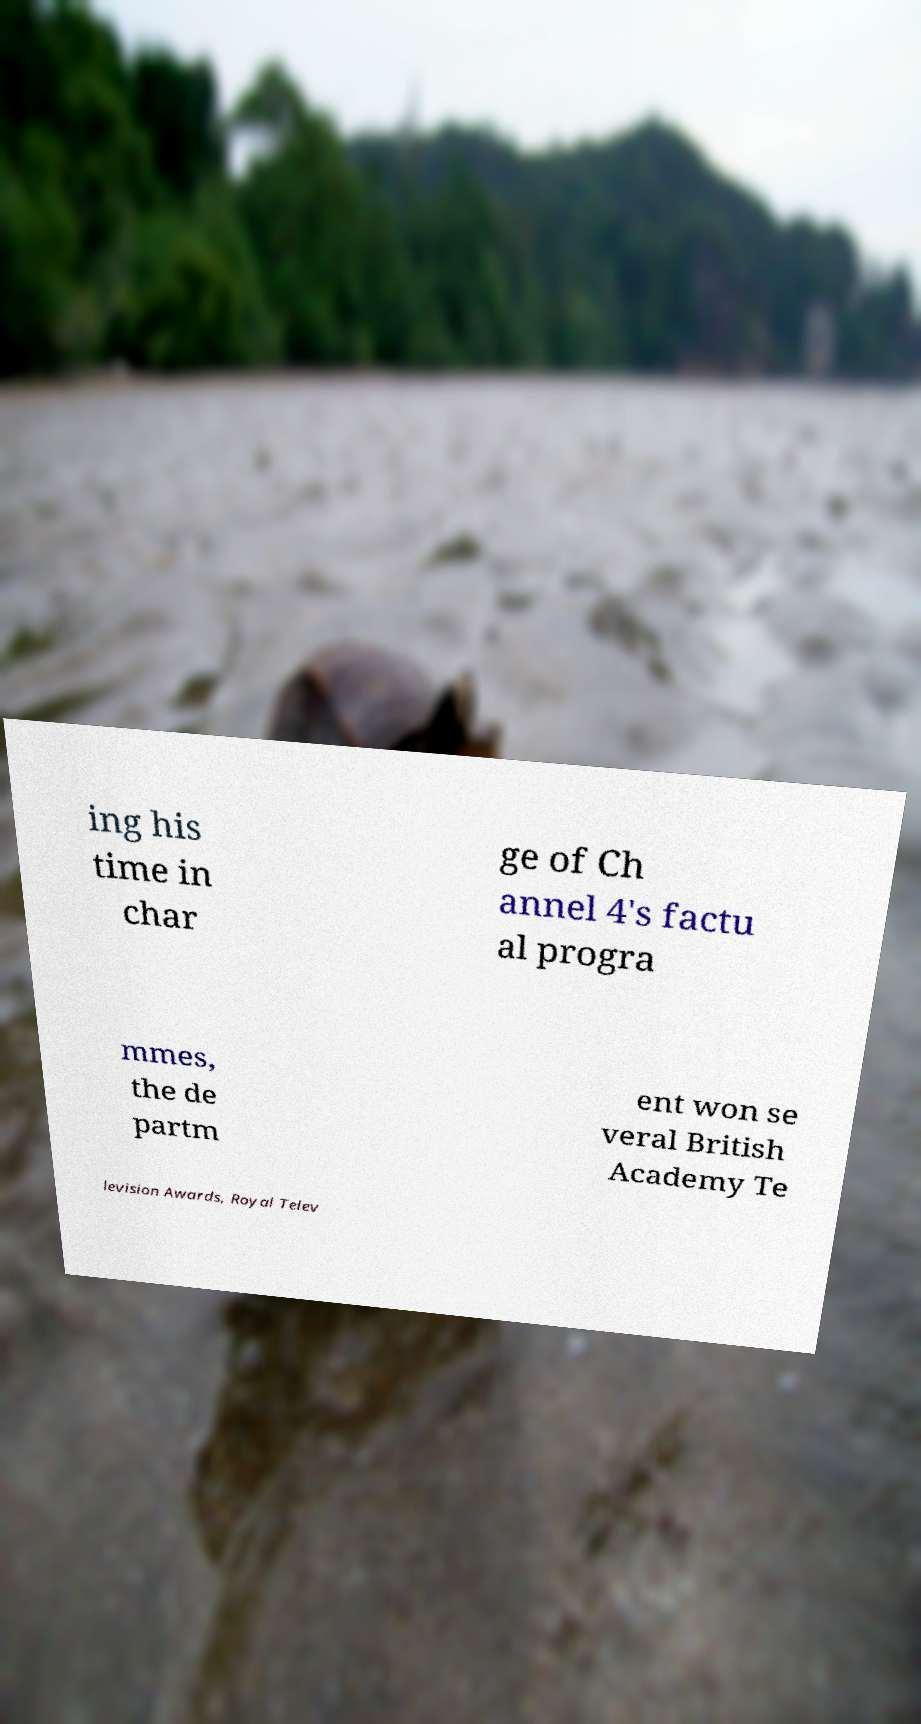Can you accurately transcribe the text from the provided image for me? ing his time in char ge of Ch annel 4's factu al progra mmes, the de partm ent won se veral British Academy Te levision Awards, Royal Telev 